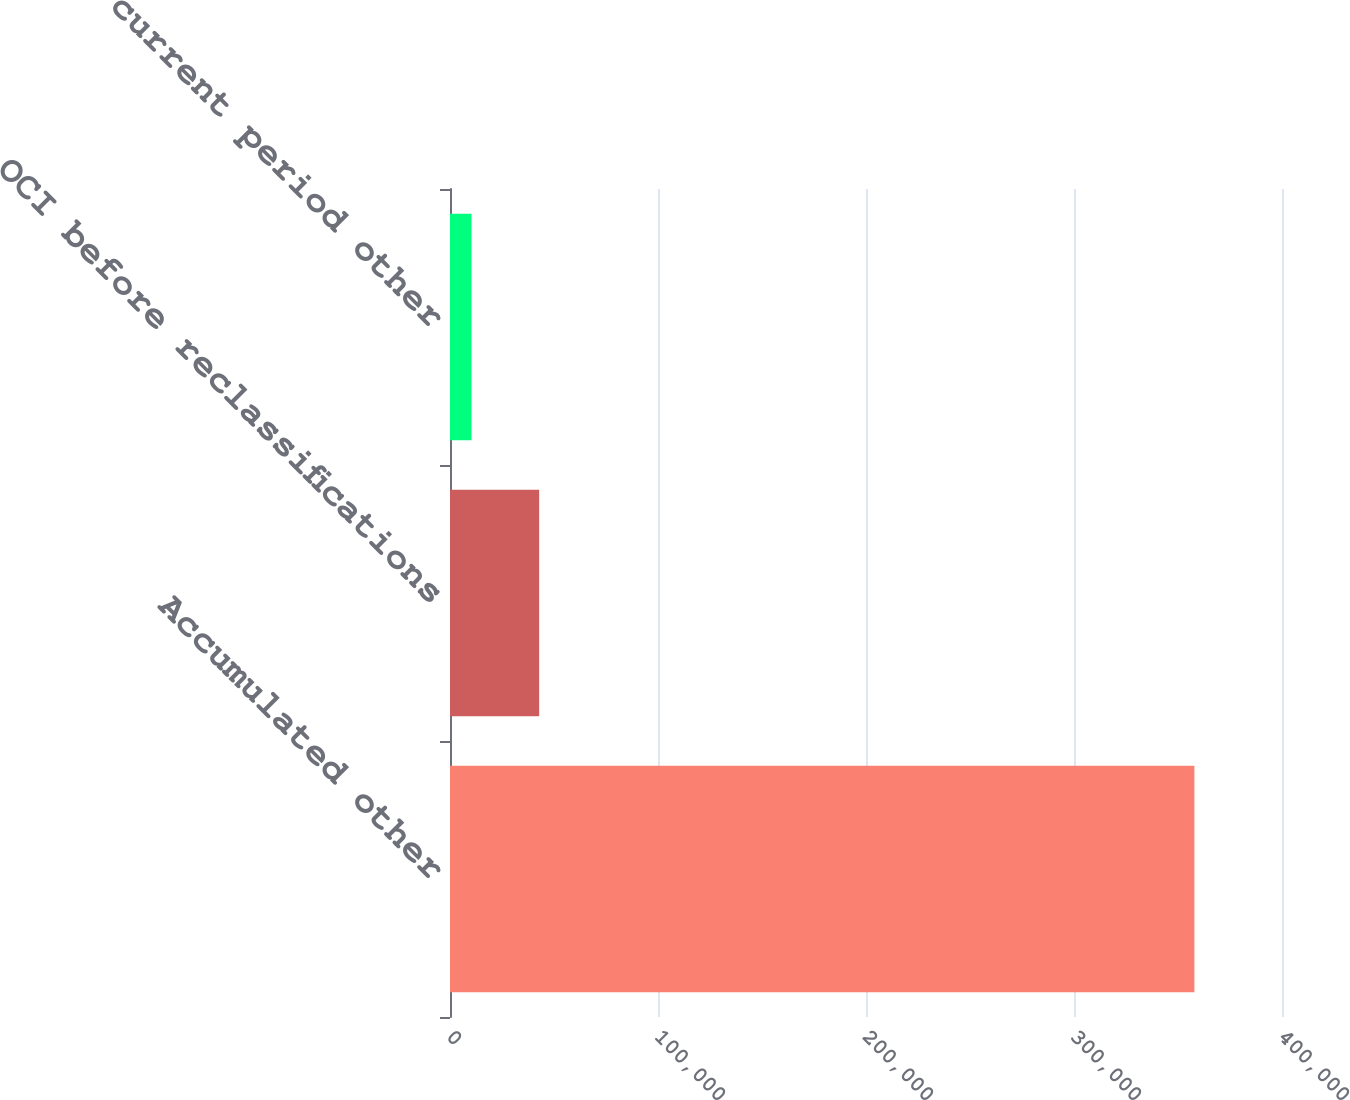Convert chart. <chart><loc_0><loc_0><loc_500><loc_500><bar_chart><fcel>Accumulated other<fcel>OCI before reclassifications<fcel>Net current period other<nl><fcel>357876<fcel>42866.2<fcel>10332<nl></chart> 